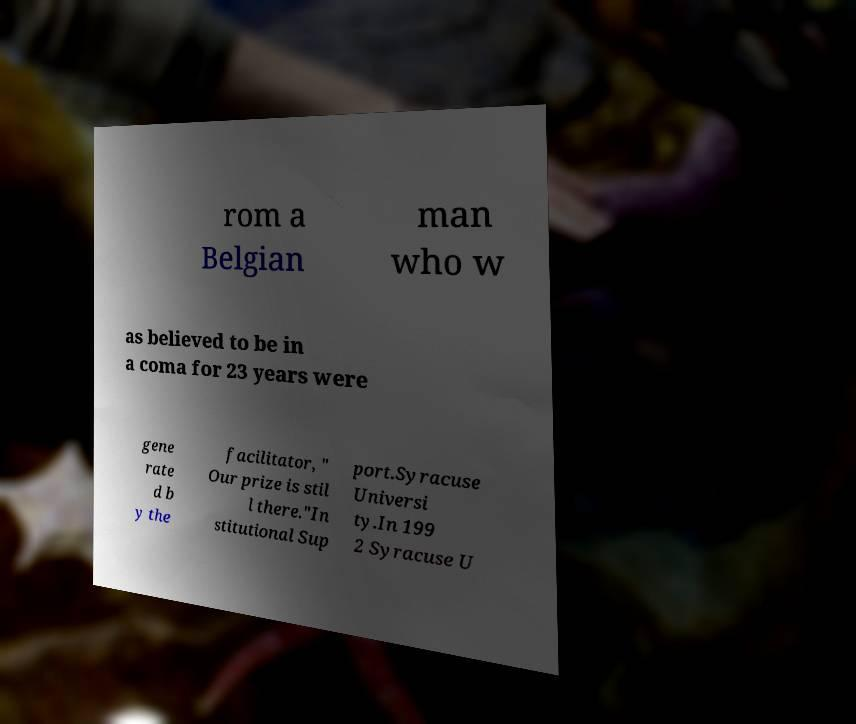Could you extract and type out the text from this image? rom a Belgian man who w as believed to be in a coma for 23 years were gene rate d b y the facilitator, " Our prize is stil l there."In stitutional Sup port.Syracuse Universi ty.In 199 2 Syracuse U 